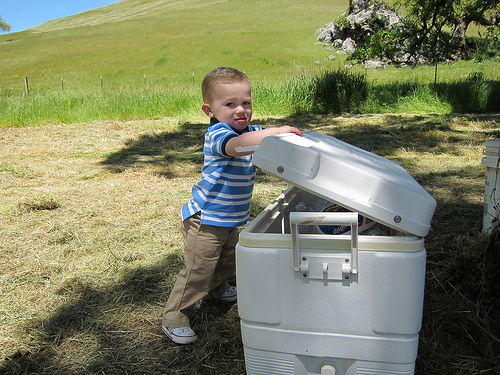<image>
Is there a baby to the right of the box? No. The baby is not to the right of the box. The horizontal positioning shows a different relationship. 